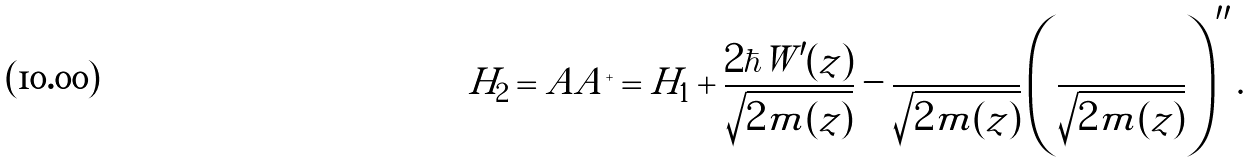Convert formula to latex. <formula><loc_0><loc_0><loc_500><loc_500>H _ { 2 } = A A ^ { + } = H _ { 1 } + \frac { 2 \hbar { W } ^ { \prime } ( z ) } { \sqrt { 2 m ( z ) } } - \frac { } { \sqrt { 2 m ( z ) } } \left ( \frac { } { \sqrt { 2 m ( z ) } } \right ) ^ { \prime \prime } .</formula> 